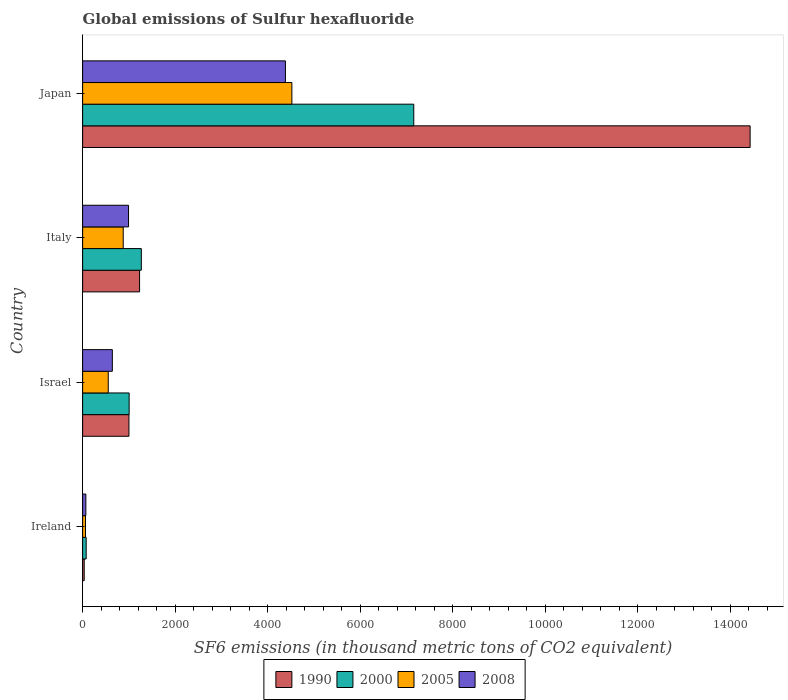How many bars are there on the 1st tick from the top?
Give a very brief answer. 4. How many bars are there on the 4th tick from the bottom?
Offer a very short reply. 4. In how many cases, is the number of bars for a given country not equal to the number of legend labels?
Ensure brevity in your answer.  0. What is the global emissions of Sulfur hexafluoride in 2000 in Italy?
Offer a terse response. 1268.5. Across all countries, what is the maximum global emissions of Sulfur hexafluoride in 1990?
Your answer should be very brief. 1.44e+04. Across all countries, what is the minimum global emissions of Sulfur hexafluoride in 2000?
Your response must be concise. 76.5. In which country was the global emissions of Sulfur hexafluoride in 2000 maximum?
Keep it short and to the point. Japan. In which country was the global emissions of Sulfur hexafluoride in 2005 minimum?
Your response must be concise. Ireland. What is the total global emissions of Sulfur hexafluoride in 1990 in the graph?
Provide a short and direct response. 1.67e+04. What is the difference between the global emissions of Sulfur hexafluoride in 2005 in Ireland and that in Italy?
Your answer should be very brief. -815.4. What is the difference between the global emissions of Sulfur hexafluoride in 1990 in Japan and the global emissions of Sulfur hexafluoride in 2005 in Italy?
Your response must be concise. 1.35e+04. What is the average global emissions of Sulfur hexafluoride in 2005 per country?
Provide a succinct answer. 1503.75. What is the ratio of the global emissions of Sulfur hexafluoride in 1990 in Ireland to that in Japan?
Make the answer very short. 0. Is the difference between the global emissions of Sulfur hexafluoride in 2005 in Italy and Japan greater than the difference between the global emissions of Sulfur hexafluoride in 1990 in Italy and Japan?
Keep it short and to the point. Yes. What is the difference between the highest and the second highest global emissions of Sulfur hexafluoride in 1990?
Keep it short and to the point. 1.32e+04. What is the difference between the highest and the lowest global emissions of Sulfur hexafluoride in 2005?
Give a very brief answer. 4460.5. In how many countries, is the global emissions of Sulfur hexafluoride in 1990 greater than the average global emissions of Sulfur hexafluoride in 1990 taken over all countries?
Give a very brief answer. 1. Is the sum of the global emissions of Sulfur hexafluoride in 2005 in Israel and Italy greater than the maximum global emissions of Sulfur hexafluoride in 2000 across all countries?
Give a very brief answer. No. Is it the case that in every country, the sum of the global emissions of Sulfur hexafluoride in 2000 and global emissions of Sulfur hexafluoride in 2008 is greater than the sum of global emissions of Sulfur hexafluoride in 2005 and global emissions of Sulfur hexafluoride in 1990?
Provide a short and direct response. No. How many bars are there?
Keep it short and to the point. 16. Does the graph contain any zero values?
Keep it short and to the point. No. Does the graph contain grids?
Offer a terse response. No. How are the legend labels stacked?
Your answer should be compact. Horizontal. What is the title of the graph?
Give a very brief answer. Global emissions of Sulfur hexafluoride. What is the label or title of the X-axis?
Make the answer very short. SF6 emissions (in thousand metric tons of CO2 equivalent). What is the SF6 emissions (in thousand metric tons of CO2 equivalent) in 1990 in Ireland?
Offer a very short reply. 33.8. What is the SF6 emissions (in thousand metric tons of CO2 equivalent) of 2000 in Ireland?
Provide a short and direct response. 76.5. What is the SF6 emissions (in thousand metric tons of CO2 equivalent) of 2005 in Ireland?
Your answer should be very brief. 61.8. What is the SF6 emissions (in thousand metric tons of CO2 equivalent) of 2008 in Ireland?
Give a very brief answer. 69.9. What is the SF6 emissions (in thousand metric tons of CO2 equivalent) in 1990 in Israel?
Keep it short and to the point. 1001. What is the SF6 emissions (in thousand metric tons of CO2 equivalent) of 2000 in Israel?
Keep it short and to the point. 1005.2. What is the SF6 emissions (in thousand metric tons of CO2 equivalent) of 2005 in Israel?
Your answer should be very brief. 553.7. What is the SF6 emissions (in thousand metric tons of CO2 equivalent) in 2008 in Israel?
Your answer should be compact. 642. What is the SF6 emissions (in thousand metric tons of CO2 equivalent) of 1990 in Italy?
Make the answer very short. 1230.8. What is the SF6 emissions (in thousand metric tons of CO2 equivalent) in 2000 in Italy?
Your response must be concise. 1268.5. What is the SF6 emissions (in thousand metric tons of CO2 equivalent) in 2005 in Italy?
Your answer should be compact. 877.2. What is the SF6 emissions (in thousand metric tons of CO2 equivalent) in 2008 in Italy?
Offer a very short reply. 992.1. What is the SF6 emissions (in thousand metric tons of CO2 equivalent) of 1990 in Japan?
Your answer should be very brief. 1.44e+04. What is the SF6 emissions (in thousand metric tons of CO2 equivalent) in 2000 in Japan?
Offer a very short reply. 7156.6. What is the SF6 emissions (in thousand metric tons of CO2 equivalent) of 2005 in Japan?
Offer a terse response. 4522.3. What is the SF6 emissions (in thousand metric tons of CO2 equivalent) in 2008 in Japan?
Give a very brief answer. 4382.7. Across all countries, what is the maximum SF6 emissions (in thousand metric tons of CO2 equivalent) of 1990?
Provide a succinct answer. 1.44e+04. Across all countries, what is the maximum SF6 emissions (in thousand metric tons of CO2 equivalent) in 2000?
Offer a very short reply. 7156.6. Across all countries, what is the maximum SF6 emissions (in thousand metric tons of CO2 equivalent) in 2005?
Provide a short and direct response. 4522.3. Across all countries, what is the maximum SF6 emissions (in thousand metric tons of CO2 equivalent) in 2008?
Keep it short and to the point. 4382.7. Across all countries, what is the minimum SF6 emissions (in thousand metric tons of CO2 equivalent) of 1990?
Your response must be concise. 33.8. Across all countries, what is the minimum SF6 emissions (in thousand metric tons of CO2 equivalent) of 2000?
Ensure brevity in your answer.  76.5. Across all countries, what is the minimum SF6 emissions (in thousand metric tons of CO2 equivalent) in 2005?
Your answer should be very brief. 61.8. Across all countries, what is the minimum SF6 emissions (in thousand metric tons of CO2 equivalent) in 2008?
Provide a succinct answer. 69.9. What is the total SF6 emissions (in thousand metric tons of CO2 equivalent) of 1990 in the graph?
Give a very brief answer. 1.67e+04. What is the total SF6 emissions (in thousand metric tons of CO2 equivalent) of 2000 in the graph?
Provide a short and direct response. 9506.8. What is the total SF6 emissions (in thousand metric tons of CO2 equivalent) in 2005 in the graph?
Your answer should be very brief. 6015. What is the total SF6 emissions (in thousand metric tons of CO2 equivalent) of 2008 in the graph?
Provide a short and direct response. 6086.7. What is the difference between the SF6 emissions (in thousand metric tons of CO2 equivalent) in 1990 in Ireland and that in Israel?
Offer a terse response. -967.2. What is the difference between the SF6 emissions (in thousand metric tons of CO2 equivalent) of 2000 in Ireland and that in Israel?
Your response must be concise. -928.7. What is the difference between the SF6 emissions (in thousand metric tons of CO2 equivalent) in 2005 in Ireland and that in Israel?
Provide a succinct answer. -491.9. What is the difference between the SF6 emissions (in thousand metric tons of CO2 equivalent) of 2008 in Ireland and that in Israel?
Keep it short and to the point. -572.1. What is the difference between the SF6 emissions (in thousand metric tons of CO2 equivalent) of 1990 in Ireland and that in Italy?
Offer a terse response. -1197. What is the difference between the SF6 emissions (in thousand metric tons of CO2 equivalent) of 2000 in Ireland and that in Italy?
Your response must be concise. -1192. What is the difference between the SF6 emissions (in thousand metric tons of CO2 equivalent) in 2005 in Ireland and that in Italy?
Your answer should be compact. -815.4. What is the difference between the SF6 emissions (in thousand metric tons of CO2 equivalent) in 2008 in Ireland and that in Italy?
Make the answer very short. -922.2. What is the difference between the SF6 emissions (in thousand metric tons of CO2 equivalent) of 1990 in Ireland and that in Japan?
Provide a short and direct response. -1.44e+04. What is the difference between the SF6 emissions (in thousand metric tons of CO2 equivalent) of 2000 in Ireland and that in Japan?
Make the answer very short. -7080.1. What is the difference between the SF6 emissions (in thousand metric tons of CO2 equivalent) of 2005 in Ireland and that in Japan?
Offer a very short reply. -4460.5. What is the difference between the SF6 emissions (in thousand metric tons of CO2 equivalent) of 2008 in Ireland and that in Japan?
Provide a short and direct response. -4312.8. What is the difference between the SF6 emissions (in thousand metric tons of CO2 equivalent) of 1990 in Israel and that in Italy?
Your response must be concise. -229.8. What is the difference between the SF6 emissions (in thousand metric tons of CO2 equivalent) of 2000 in Israel and that in Italy?
Offer a terse response. -263.3. What is the difference between the SF6 emissions (in thousand metric tons of CO2 equivalent) of 2005 in Israel and that in Italy?
Provide a succinct answer. -323.5. What is the difference between the SF6 emissions (in thousand metric tons of CO2 equivalent) in 2008 in Israel and that in Italy?
Offer a terse response. -350.1. What is the difference between the SF6 emissions (in thousand metric tons of CO2 equivalent) in 1990 in Israel and that in Japan?
Provide a succinct answer. -1.34e+04. What is the difference between the SF6 emissions (in thousand metric tons of CO2 equivalent) of 2000 in Israel and that in Japan?
Ensure brevity in your answer.  -6151.4. What is the difference between the SF6 emissions (in thousand metric tons of CO2 equivalent) of 2005 in Israel and that in Japan?
Provide a succinct answer. -3968.6. What is the difference between the SF6 emissions (in thousand metric tons of CO2 equivalent) of 2008 in Israel and that in Japan?
Provide a succinct answer. -3740.7. What is the difference between the SF6 emissions (in thousand metric tons of CO2 equivalent) in 1990 in Italy and that in Japan?
Your answer should be compact. -1.32e+04. What is the difference between the SF6 emissions (in thousand metric tons of CO2 equivalent) in 2000 in Italy and that in Japan?
Your answer should be very brief. -5888.1. What is the difference between the SF6 emissions (in thousand metric tons of CO2 equivalent) in 2005 in Italy and that in Japan?
Ensure brevity in your answer.  -3645.1. What is the difference between the SF6 emissions (in thousand metric tons of CO2 equivalent) of 2008 in Italy and that in Japan?
Ensure brevity in your answer.  -3390.6. What is the difference between the SF6 emissions (in thousand metric tons of CO2 equivalent) of 1990 in Ireland and the SF6 emissions (in thousand metric tons of CO2 equivalent) of 2000 in Israel?
Your response must be concise. -971.4. What is the difference between the SF6 emissions (in thousand metric tons of CO2 equivalent) of 1990 in Ireland and the SF6 emissions (in thousand metric tons of CO2 equivalent) of 2005 in Israel?
Offer a very short reply. -519.9. What is the difference between the SF6 emissions (in thousand metric tons of CO2 equivalent) in 1990 in Ireland and the SF6 emissions (in thousand metric tons of CO2 equivalent) in 2008 in Israel?
Ensure brevity in your answer.  -608.2. What is the difference between the SF6 emissions (in thousand metric tons of CO2 equivalent) in 2000 in Ireland and the SF6 emissions (in thousand metric tons of CO2 equivalent) in 2005 in Israel?
Provide a short and direct response. -477.2. What is the difference between the SF6 emissions (in thousand metric tons of CO2 equivalent) of 2000 in Ireland and the SF6 emissions (in thousand metric tons of CO2 equivalent) of 2008 in Israel?
Your answer should be compact. -565.5. What is the difference between the SF6 emissions (in thousand metric tons of CO2 equivalent) of 2005 in Ireland and the SF6 emissions (in thousand metric tons of CO2 equivalent) of 2008 in Israel?
Offer a very short reply. -580.2. What is the difference between the SF6 emissions (in thousand metric tons of CO2 equivalent) of 1990 in Ireland and the SF6 emissions (in thousand metric tons of CO2 equivalent) of 2000 in Italy?
Offer a terse response. -1234.7. What is the difference between the SF6 emissions (in thousand metric tons of CO2 equivalent) in 1990 in Ireland and the SF6 emissions (in thousand metric tons of CO2 equivalent) in 2005 in Italy?
Ensure brevity in your answer.  -843.4. What is the difference between the SF6 emissions (in thousand metric tons of CO2 equivalent) in 1990 in Ireland and the SF6 emissions (in thousand metric tons of CO2 equivalent) in 2008 in Italy?
Provide a succinct answer. -958.3. What is the difference between the SF6 emissions (in thousand metric tons of CO2 equivalent) of 2000 in Ireland and the SF6 emissions (in thousand metric tons of CO2 equivalent) of 2005 in Italy?
Provide a short and direct response. -800.7. What is the difference between the SF6 emissions (in thousand metric tons of CO2 equivalent) in 2000 in Ireland and the SF6 emissions (in thousand metric tons of CO2 equivalent) in 2008 in Italy?
Offer a very short reply. -915.6. What is the difference between the SF6 emissions (in thousand metric tons of CO2 equivalent) of 2005 in Ireland and the SF6 emissions (in thousand metric tons of CO2 equivalent) of 2008 in Italy?
Make the answer very short. -930.3. What is the difference between the SF6 emissions (in thousand metric tons of CO2 equivalent) of 1990 in Ireland and the SF6 emissions (in thousand metric tons of CO2 equivalent) of 2000 in Japan?
Your response must be concise. -7122.8. What is the difference between the SF6 emissions (in thousand metric tons of CO2 equivalent) of 1990 in Ireland and the SF6 emissions (in thousand metric tons of CO2 equivalent) of 2005 in Japan?
Provide a succinct answer. -4488.5. What is the difference between the SF6 emissions (in thousand metric tons of CO2 equivalent) in 1990 in Ireland and the SF6 emissions (in thousand metric tons of CO2 equivalent) in 2008 in Japan?
Provide a short and direct response. -4348.9. What is the difference between the SF6 emissions (in thousand metric tons of CO2 equivalent) in 2000 in Ireland and the SF6 emissions (in thousand metric tons of CO2 equivalent) in 2005 in Japan?
Your answer should be compact. -4445.8. What is the difference between the SF6 emissions (in thousand metric tons of CO2 equivalent) of 2000 in Ireland and the SF6 emissions (in thousand metric tons of CO2 equivalent) of 2008 in Japan?
Your answer should be very brief. -4306.2. What is the difference between the SF6 emissions (in thousand metric tons of CO2 equivalent) in 2005 in Ireland and the SF6 emissions (in thousand metric tons of CO2 equivalent) in 2008 in Japan?
Offer a terse response. -4320.9. What is the difference between the SF6 emissions (in thousand metric tons of CO2 equivalent) in 1990 in Israel and the SF6 emissions (in thousand metric tons of CO2 equivalent) in 2000 in Italy?
Offer a terse response. -267.5. What is the difference between the SF6 emissions (in thousand metric tons of CO2 equivalent) of 1990 in Israel and the SF6 emissions (in thousand metric tons of CO2 equivalent) of 2005 in Italy?
Ensure brevity in your answer.  123.8. What is the difference between the SF6 emissions (in thousand metric tons of CO2 equivalent) in 1990 in Israel and the SF6 emissions (in thousand metric tons of CO2 equivalent) in 2008 in Italy?
Make the answer very short. 8.9. What is the difference between the SF6 emissions (in thousand metric tons of CO2 equivalent) in 2000 in Israel and the SF6 emissions (in thousand metric tons of CO2 equivalent) in 2005 in Italy?
Your answer should be very brief. 128. What is the difference between the SF6 emissions (in thousand metric tons of CO2 equivalent) in 2000 in Israel and the SF6 emissions (in thousand metric tons of CO2 equivalent) in 2008 in Italy?
Make the answer very short. 13.1. What is the difference between the SF6 emissions (in thousand metric tons of CO2 equivalent) in 2005 in Israel and the SF6 emissions (in thousand metric tons of CO2 equivalent) in 2008 in Italy?
Make the answer very short. -438.4. What is the difference between the SF6 emissions (in thousand metric tons of CO2 equivalent) in 1990 in Israel and the SF6 emissions (in thousand metric tons of CO2 equivalent) in 2000 in Japan?
Make the answer very short. -6155.6. What is the difference between the SF6 emissions (in thousand metric tons of CO2 equivalent) in 1990 in Israel and the SF6 emissions (in thousand metric tons of CO2 equivalent) in 2005 in Japan?
Your answer should be very brief. -3521.3. What is the difference between the SF6 emissions (in thousand metric tons of CO2 equivalent) of 1990 in Israel and the SF6 emissions (in thousand metric tons of CO2 equivalent) of 2008 in Japan?
Keep it short and to the point. -3381.7. What is the difference between the SF6 emissions (in thousand metric tons of CO2 equivalent) of 2000 in Israel and the SF6 emissions (in thousand metric tons of CO2 equivalent) of 2005 in Japan?
Provide a succinct answer. -3517.1. What is the difference between the SF6 emissions (in thousand metric tons of CO2 equivalent) in 2000 in Israel and the SF6 emissions (in thousand metric tons of CO2 equivalent) in 2008 in Japan?
Your response must be concise. -3377.5. What is the difference between the SF6 emissions (in thousand metric tons of CO2 equivalent) of 2005 in Israel and the SF6 emissions (in thousand metric tons of CO2 equivalent) of 2008 in Japan?
Your answer should be very brief. -3829. What is the difference between the SF6 emissions (in thousand metric tons of CO2 equivalent) in 1990 in Italy and the SF6 emissions (in thousand metric tons of CO2 equivalent) in 2000 in Japan?
Make the answer very short. -5925.8. What is the difference between the SF6 emissions (in thousand metric tons of CO2 equivalent) of 1990 in Italy and the SF6 emissions (in thousand metric tons of CO2 equivalent) of 2005 in Japan?
Give a very brief answer. -3291.5. What is the difference between the SF6 emissions (in thousand metric tons of CO2 equivalent) of 1990 in Italy and the SF6 emissions (in thousand metric tons of CO2 equivalent) of 2008 in Japan?
Offer a terse response. -3151.9. What is the difference between the SF6 emissions (in thousand metric tons of CO2 equivalent) in 2000 in Italy and the SF6 emissions (in thousand metric tons of CO2 equivalent) in 2005 in Japan?
Your answer should be compact. -3253.8. What is the difference between the SF6 emissions (in thousand metric tons of CO2 equivalent) in 2000 in Italy and the SF6 emissions (in thousand metric tons of CO2 equivalent) in 2008 in Japan?
Your response must be concise. -3114.2. What is the difference between the SF6 emissions (in thousand metric tons of CO2 equivalent) of 2005 in Italy and the SF6 emissions (in thousand metric tons of CO2 equivalent) of 2008 in Japan?
Offer a very short reply. -3505.5. What is the average SF6 emissions (in thousand metric tons of CO2 equivalent) in 1990 per country?
Offer a very short reply. 4172.85. What is the average SF6 emissions (in thousand metric tons of CO2 equivalent) in 2000 per country?
Your answer should be compact. 2376.7. What is the average SF6 emissions (in thousand metric tons of CO2 equivalent) of 2005 per country?
Your answer should be very brief. 1503.75. What is the average SF6 emissions (in thousand metric tons of CO2 equivalent) of 2008 per country?
Keep it short and to the point. 1521.67. What is the difference between the SF6 emissions (in thousand metric tons of CO2 equivalent) in 1990 and SF6 emissions (in thousand metric tons of CO2 equivalent) in 2000 in Ireland?
Keep it short and to the point. -42.7. What is the difference between the SF6 emissions (in thousand metric tons of CO2 equivalent) in 1990 and SF6 emissions (in thousand metric tons of CO2 equivalent) in 2008 in Ireland?
Offer a very short reply. -36.1. What is the difference between the SF6 emissions (in thousand metric tons of CO2 equivalent) in 1990 and SF6 emissions (in thousand metric tons of CO2 equivalent) in 2000 in Israel?
Give a very brief answer. -4.2. What is the difference between the SF6 emissions (in thousand metric tons of CO2 equivalent) in 1990 and SF6 emissions (in thousand metric tons of CO2 equivalent) in 2005 in Israel?
Your response must be concise. 447.3. What is the difference between the SF6 emissions (in thousand metric tons of CO2 equivalent) of 1990 and SF6 emissions (in thousand metric tons of CO2 equivalent) of 2008 in Israel?
Your response must be concise. 359. What is the difference between the SF6 emissions (in thousand metric tons of CO2 equivalent) of 2000 and SF6 emissions (in thousand metric tons of CO2 equivalent) of 2005 in Israel?
Keep it short and to the point. 451.5. What is the difference between the SF6 emissions (in thousand metric tons of CO2 equivalent) in 2000 and SF6 emissions (in thousand metric tons of CO2 equivalent) in 2008 in Israel?
Make the answer very short. 363.2. What is the difference between the SF6 emissions (in thousand metric tons of CO2 equivalent) of 2005 and SF6 emissions (in thousand metric tons of CO2 equivalent) of 2008 in Israel?
Ensure brevity in your answer.  -88.3. What is the difference between the SF6 emissions (in thousand metric tons of CO2 equivalent) of 1990 and SF6 emissions (in thousand metric tons of CO2 equivalent) of 2000 in Italy?
Offer a terse response. -37.7. What is the difference between the SF6 emissions (in thousand metric tons of CO2 equivalent) of 1990 and SF6 emissions (in thousand metric tons of CO2 equivalent) of 2005 in Italy?
Offer a very short reply. 353.6. What is the difference between the SF6 emissions (in thousand metric tons of CO2 equivalent) in 1990 and SF6 emissions (in thousand metric tons of CO2 equivalent) in 2008 in Italy?
Your answer should be very brief. 238.7. What is the difference between the SF6 emissions (in thousand metric tons of CO2 equivalent) in 2000 and SF6 emissions (in thousand metric tons of CO2 equivalent) in 2005 in Italy?
Provide a short and direct response. 391.3. What is the difference between the SF6 emissions (in thousand metric tons of CO2 equivalent) in 2000 and SF6 emissions (in thousand metric tons of CO2 equivalent) in 2008 in Italy?
Give a very brief answer. 276.4. What is the difference between the SF6 emissions (in thousand metric tons of CO2 equivalent) of 2005 and SF6 emissions (in thousand metric tons of CO2 equivalent) of 2008 in Italy?
Make the answer very short. -114.9. What is the difference between the SF6 emissions (in thousand metric tons of CO2 equivalent) in 1990 and SF6 emissions (in thousand metric tons of CO2 equivalent) in 2000 in Japan?
Keep it short and to the point. 7269.2. What is the difference between the SF6 emissions (in thousand metric tons of CO2 equivalent) of 1990 and SF6 emissions (in thousand metric tons of CO2 equivalent) of 2005 in Japan?
Ensure brevity in your answer.  9903.5. What is the difference between the SF6 emissions (in thousand metric tons of CO2 equivalent) in 1990 and SF6 emissions (in thousand metric tons of CO2 equivalent) in 2008 in Japan?
Your response must be concise. 1.00e+04. What is the difference between the SF6 emissions (in thousand metric tons of CO2 equivalent) in 2000 and SF6 emissions (in thousand metric tons of CO2 equivalent) in 2005 in Japan?
Provide a short and direct response. 2634.3. What is the difference between the SF6 emissions (in thousand metric tons of CO2 equivalent) in 2000 and SF6 emissions (in thousand metric tons of CO2 equivalent) in 2008 in Japan?
Offer a very short reply. 2773.9. What is the difference between the SF6 emissions (in thousand metric tons of CO2 equivalent) of 2005 and SF6 emissions (in thousand metric tons of CO2 equivalent) of 2008 in Japan?
Your answer should be compact. 139.6. What is the ratio of the SF6 emissions (in thousand metric tons of CO2 equivalent) in 1990 in Ireland to that in Israel?
Provide a succinct answer. 0.03. What is the ratio of the SF6 emissions (in thousand metric tons of CO2 equivalent) in 2000 in Ireland to that in Israel?
Your answer should be very brief. 0.08. What is the ratio of the SF6 emissions (in thousand metric tons of CO2 equivalent) in 2005 in Ireland to that in Israel?
Provide a succinct answer. 0.11. What is the ratio of the SF6 emissions (in thousand metric tons of CO2 equivalent) of 2008 in Ireland to that in Israel?
Give a very brief answer. 0.11. What is the ratio of the SF6 emissions (in thousand metric tons of CO2 equivalent) in 1990 in Ireland to that in Italy?
Your response must be concise. 0.03. What is the ratio of the SF6 emissions (in thousand metric tons of CO2 equivalent) of 2000 in Ireland to that in Italy?
Provide a succinct answer. 0.06. What is the ratio of the SF6 emissions (in thousand metric tons of CO2 equivalent) in 2005 in Ireland to that in Italy?
Provide a succinct answer. 0.07. What is the ratio of the SF6 emissions (in thousand metric tons of CO2 equivalent) of 2008 in Ireland to that in Italy?
Provide a short and direct response. 0.07. What is the ratio of the SF6 emissions (in thousand metric tons of CO2 equivalent) in 1990 in Ireland to that in Japan?
Keep it short and to the point. 0. What is the ratio of the SF6 emissions (in thousand metric tons of CO2 equivalent) in 2000 in Ireland to that in Japan?
Offer a very short reply. 0.01. What is the ratio of the SF6 emissions (in thousand metric tons of CO2 equivalent) of 2005 in Ireland to that in Japan?
Ensure brevity in your answer.  0.01. What is the ratio of the SF6 emissions (in thousand metric tons of CO2 equivalent) in 2008 in Ireland to that in Japan?
Your answer should be very brief. 0.02. What is the ratio of the SF6 emissions (in thousand metric tons of CO2 equivalent) of 1990 in Israel to that in Italy?
Ensure brevity in your answer.  0.81. What is the ratio of the SF6 emissions (in thousand metric tons of CO2 equivalent) of 2000 in Israel to that in Italy?
Give a very brief answer. 0.79. What is the ratio of the SF6 emissions (in thousand metric tons of CO2 equivalent) in 2005 in Israel to that in Italy?
Offer a terse response. 0.63. What is the ratio of the SF6 emissions (in thousand metric tons of CO2 equivalent) in 2008 in Israel to that in Italy?
Your answer should be compact. 0.65. What is the ratio of the SF6 emissions (in thousand metric tons of CO2 equivalent) in 1990 in Israel to that in Japan?
Provide a short and direct response. 0.07. What is the ratio of the SF6 emissions (in thousand metric tons of CO2 equivalent) of 2000 in Israel to that in Japan?
Provide a succinct answer. 0.14. What is the ratio of the SF6 emissions (in thousand metric tons of CO2 equivalent) of 2005 in Israel to that in Japan?
Your response must be concise. 0.12. What is the ratio of the SF6 emissions (in thousand metric tons of CO2 equivalent) in 2008 in Israel to that in Japan?
Your response must be concise. 0.15. What is the ratio of the SF6 emissions (in thousand metric tons of CO2 equivalent) in 1990 in Italy to that in Japan?
Keep it short and to the point. 0.09. What is the ratio of the SF6 emissions (in thousand metric tons of CO2 equivalent) of 2000 in Italy to that in Japan?
Provide a succinct answer. 0.18. What is the ratio of the SF6 emissions (in thousand metric tons of CO2 equivalent) of 2005 in Italy to that in Japan?
Your answer should be compact. 0.19. What is the ratio of the SF6 emissions (in thousand metric tons of CO2 equivalent) of 2008 in Italy to that in Japan?
Provide a short and direct response. 0.23. What is the difference between the highest and the second highest SF6 emissions (in thousand metric tons of CO2 equivalent) of 1990?
Keep it short and to the point. 1.32e+04. What is the difference between the highest and the second highest SF6 emissions (in thousand metric tons of CO2 equivalent) of 2000?
Your response must be concise. 5888.1. What is the difference between the highest and the second highest SF6 emissions (in thousand metric tons of CO2 equivalent) of 2005?
Make the answer very short. 3645.1. What is the difference between the highest and the second highest SF6 emissions (in thousand metric tons of CO2 equivalent) of 2008?
Keep it short and to the point. 3390.6. What is the difference between the highest and the lowest SF6 emissions (in thousand metric tons of CO2 equivalent) in 1990?
Your answer should be compact. 1.44e+04. What is the difference between the highest and the lowest SF6 emissions (in thousand metric tons of CO2 equivalent) in 2000?
Provide a short and direct response. 7080.1. What is the difference between the highest and the lowest SF6 emissions (in thousand metric tons of CO2 equivalent) of 2005?
Ensure brevity in your answer.  4460.5. What is the difference between the highest and the lowest SF6 emissions (in thousand metric tons of CO2 equivalent) in 2008?
Your answer should be compact. 4312.8. 